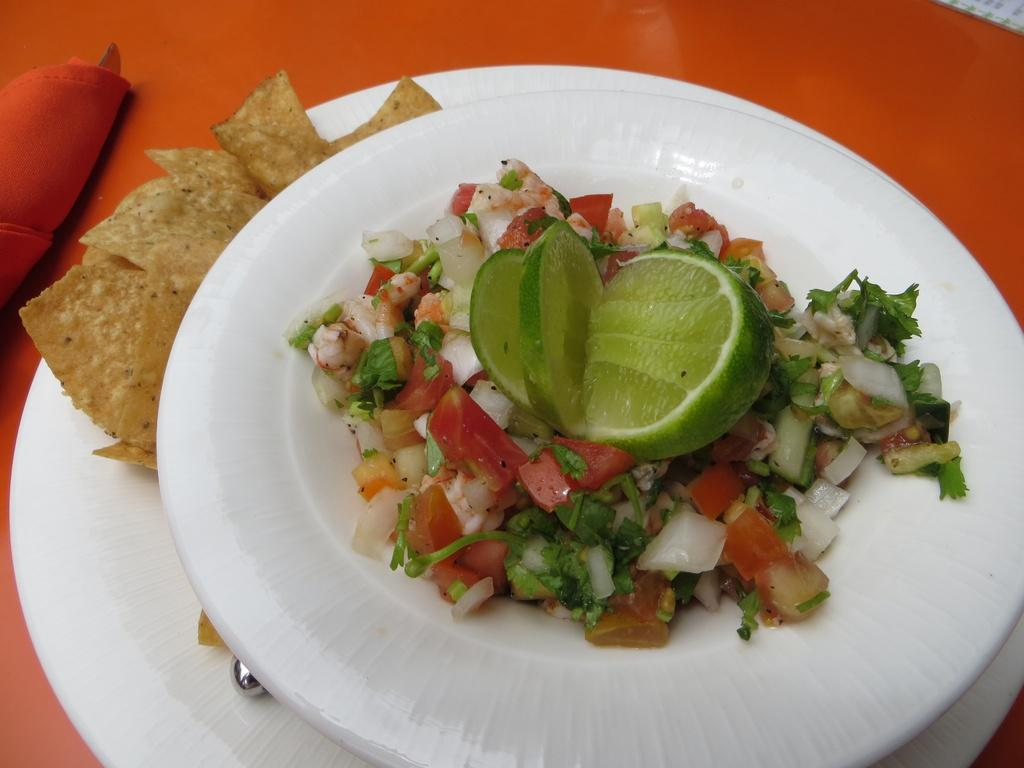What type of food can be seen in the image? There is food in the image, but the specific type is not mentioned. What fruit is present in the image? There is a lemon in the image. What utensil is visible in the image? There is a spoon in the image. How is the spoon positioned in the image? The spoon is placed on plates in the image. What object is located on the left side of the image? There is a cloth on the left side of the image. Who is the creator of the room in the image? There is no mention of a room in the image, so it is not possible to determine the creator. How many times does the lemon twist in the image? There is no indication that the lemon is twisting in the image; it is simply present. 